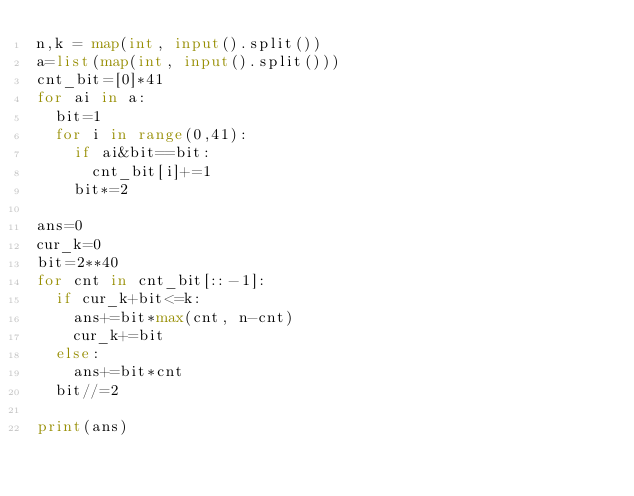<code> <loc_0><loc_0><loc_500><loc_500><_Python_>n,k = map(int, input().split())
a=list(map(int, input().split()))
cnt_bit=[0]*41
for ai in a:
  bit=1
  for i in range(0,41):
    if ai&bit==bit:
      cnt_bit[i]+=1
    bit*=2

ans=0
cur_k=0
bit=2**40
for cnt in cnt_bit[::-1]:
  if cur_k+bit<=k:
    ans+=bit*max(cnt, n-cnt)
    cur_k+=bit
  else:
    ans+=bit*cnt
  bit//=2
    
print(ans)

</code> 